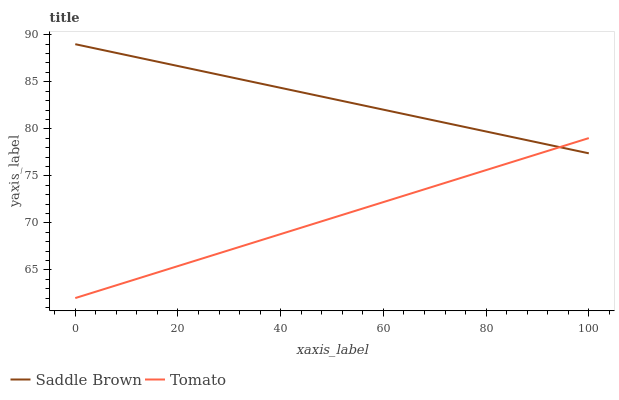Does Saddle Brown have the minimum area under the curve?
Answer yes or no. No. Is Saddle Brown the smoothest?
Answer yes or no. No. Does Saddle Brown have the lowest value?
Answer yes or no. No. 